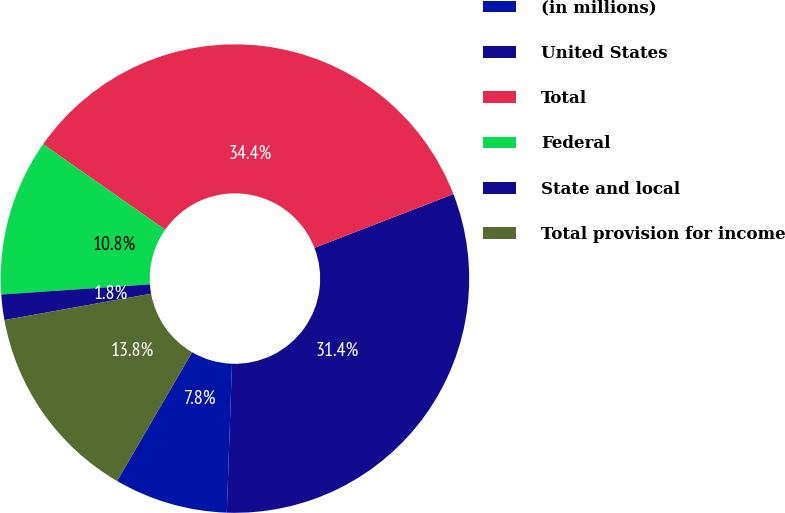Convert chart to OTSL. <chart><loc_0><loc_0><loc_500><loc_500><pie_chart><fcel>(in millions)<fcel>United States<fcel>Total<fcel>Federal<fcel>State and local<fcel>Total provision for income<nl><fcel>7.84%<fcel>31.43%<fcel>34.4%<fcel>10.81%<fcel>1.75%<fcel>13.77%<nl></chart> 